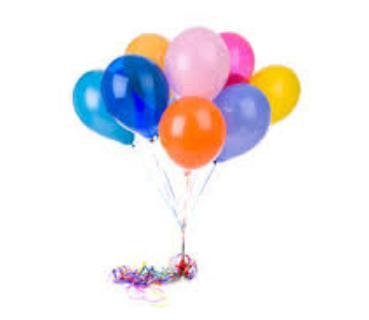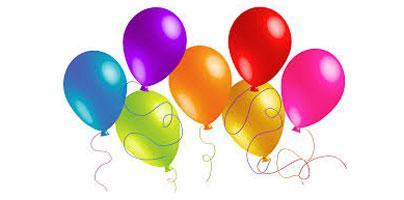The first image is the image on the left, the second image is the image on the right. Given the left and right images, does the statement "In at least one image there are many ballon made into one big balloon holding a house floating up and right." hold true? Answer yes or no. No. The first image is the image on the left, the second image is the image on the right. Considering the images on both sides, is "Exactly one image shows a mass of balloons in the shape of a hot-air balloon, with their strings coming out of a chimney of a house, and the other image shows a bunch of balloons with no house attached under them." valid? Answer yes or no. No. 